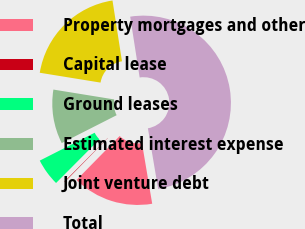Convert chart. <chart><loc_0><loc_0><loc_500><loc_500><pie_chart><fcel>Property mortgages and other<fcel>Capital lease<fcel>Ground leases<fcel>Estimated interest expense<fcel>Joint venture debt<fcel>Total<nl><fcel>15.01%<fcel>0.1%<fcel>5.07%<fcel>10.04%<fcel>19.98%<fcel>49.8%<nl></chart> 